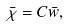<formula> <loc_0><loc_0><loc_500><loc_500>\bar { \chi } = C \bar { w } ,</formula> 